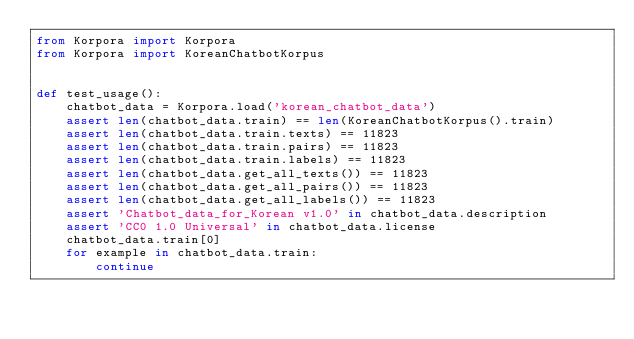<code> <loc_0><loc_0><loc_500><loc_500><_Python_>from Korpora import Korpora
from Korpora import KoreanChatbotKorpus


def test_usage():
    chatbot_data = Korpora.load('korean_chatbot_data')
    assert len(chatbot_data.train) == len(KoreanChatbotKorpus().train)
    assert len(chatbot_data.train.texts) == 11823
    assert len(chatbot_data.train.pairs) == 11823
    assert len(chatbot_data.train.labels) == 11823
    assert len(chatbot_data.get_all_texts()) == 11823
    assert len(chatbot_data.get_all_pairs()) == 11823
    assert len(chatbot_data.get_all_labels()) == 11823
    assert 'Chatbot_data_for_Korean v1.0' in chatbot_data.description
    assert 'CC0 1.0 Universal' in chatbot_data.license
    chatbot_data.train[0]
    for example in chatbot_data.train:
        continue
</code> 